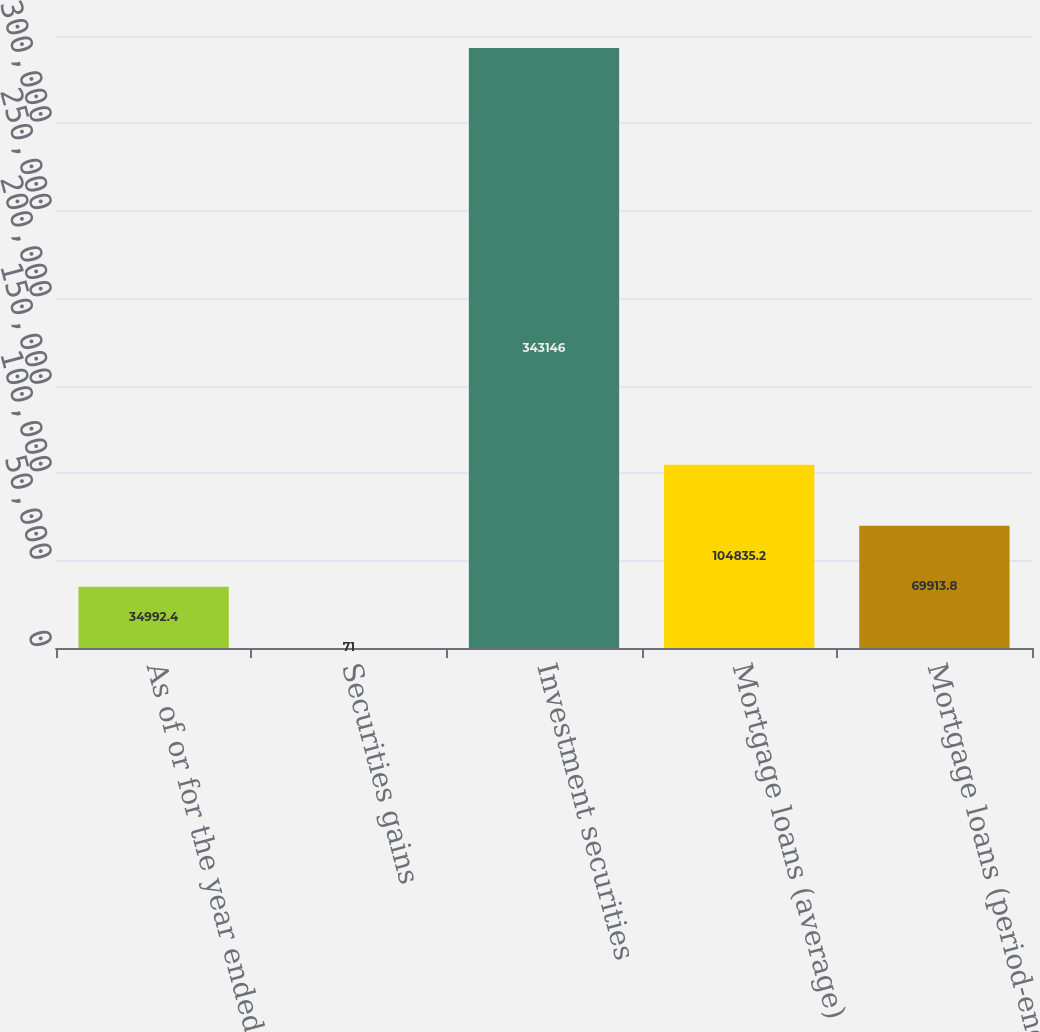Convert chart. <chart><loc_0><loc_0><loc_500><loc_500><bar_chart><fcel>As of or for the year ended<fcel>Securities gains<fcel>Investment securities<fcel>Mortgage loans (average)<fcel>Mortgage loans (period-end)<nl><fcel>34992.4<fcel>71<fcel>343146<fcel>104835<fcel>69913.8<nl></chart> 